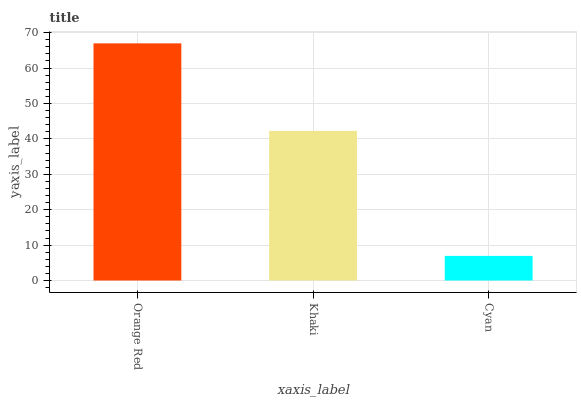Is Cyan the minimum?
Answer yes or no. Yes. Is Orange Red the maximum?
Answer yes or no. Yes. Is Khaki the minimum?
Answer yes or no. No. Is Khaki the maximum?
Answer yes or no. No. Is Orange Red greater than Khaki?
Answer yes or no. Yes. Is Khaki less than Orange Red?
Answer yes or no. Yes. Is Khaki greater than Orange Red?
Answer yes or no. No. Is Orange Red less than Khaki?
Answer yes or no. No. Is Khaki the high median?
Answer yes or no. Yes. Is Khaki the low median?
Answer yes or no. Yes. Is Cyan the high median?
Answer yes or no. No. Is Cyan the low median?
Answer yes or no. No. 